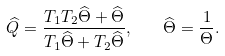<formula> <loc_0><loc_0><loc_500><loc_500>\widehat { Q } = \frac { T _ { 1 } T _ { 2 } \widehat { \Theta } + \widehat { \Theta } } { T _ { 1 } \widehat { \Theta } + T _ { 2 } \widehat { \Theta } } , \quad \widehat { \Theta } = \frac { 1 } { \Theta } .</formula> 